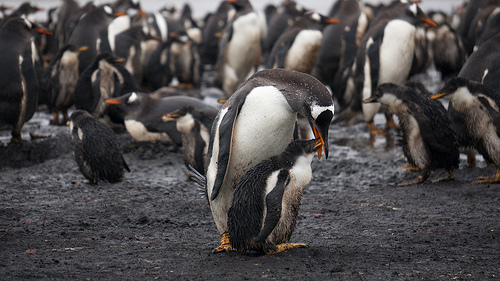<image>
Is the penguin on the ground? Yes. Looking at the image, I can see the penguin is positioned on top of the ground, with the ground providing support. Is the juvenile penguin in the penguin? No. The juvenile penguin is not contained within the penguin. These objects have a different spatial relationship. 